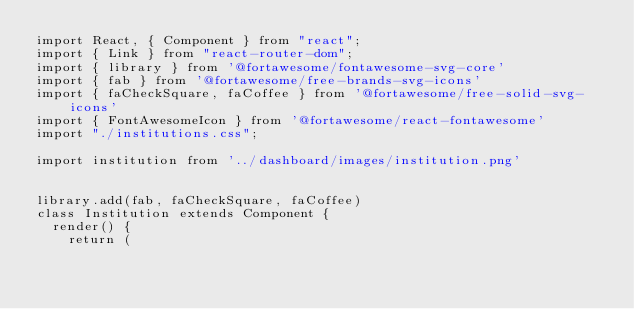<code> <loc_0><loc_0><loc_500><loc_500><_JavaScript_>import React, { Component } from "react";
import { Link } from "react-router-dom";
import { library } from '@fortawesome/fontawesome-svg-core'
import { fab } from '@fortawesome/free-brands-svg-icons'
import { faCheckSquare, faCoffee } from '@fortawesome/free-solid-svg-icons'
import { FontAwesomeIcon } from '@fortawesome/react-fontawesome'
import "./institutions.css";

import institution from '../dashboard/images/institution.png'


library.add(fab, faCheckSquare, faCoffee)
class Institution extends Component {
  render() {
    return (</code> 